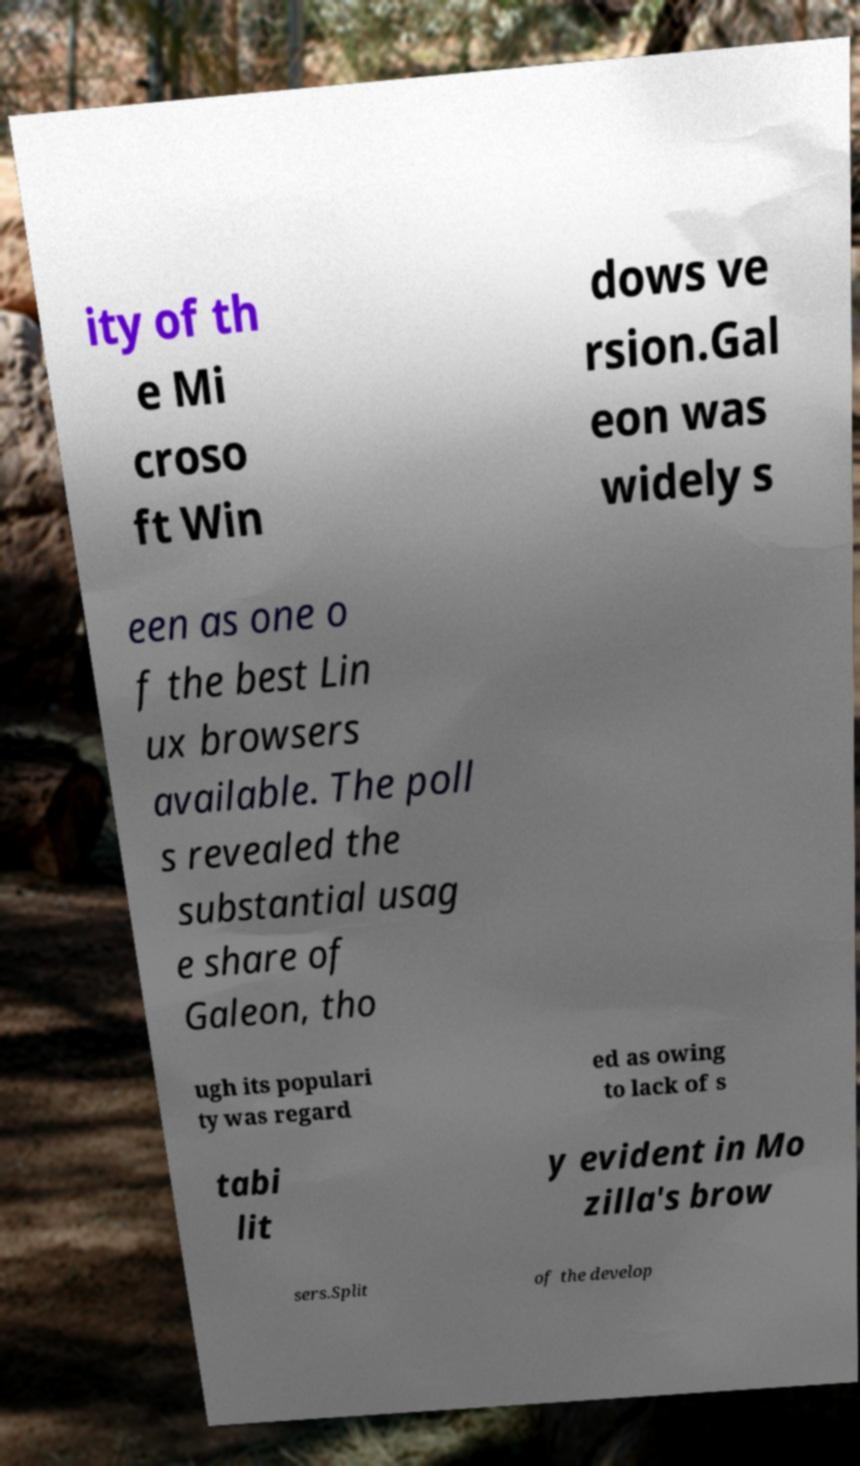Can you read and provide the text displayed in the image?This photo seems to have some interesting text. Can you extract and type it out for me? ity of th e Mi croso ft Win dows ve rsion.Gal eon was widely s een as one o f the best Lin ux browsers available. The poll s revealed the substantial usag e share of Galeon, tho ugh its populari ty was regard ed as owing to lack of s tabi lit y evident in Mo zilla's brow sers.Split of the develop 